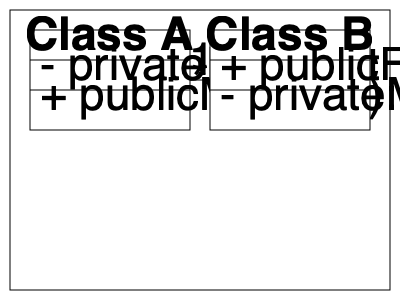Analyze the given UML class diagram and determine the relationship between Class A and Class B. What potential design issues or concerns should be considered when implementing this relationship? To analyze the UML class diagram and determine the relationship between Class A and Class B, let's follow these steps:

1. Identify the classes:
   - We have two classes: Class A and Class B

2. Examine the relationship between the classes:
   - There is a line connecting Class A and Class B
   - The line has a "1" on Class A's side and a "*" on Class B's side

3. Interpret the relationship:
   - This indicates a one-to-many association between Class A and Class B
   - One instance of Class A is associated with multiple instances of Class B

4. Analyze the class structures:
   - Class A has a private field and a public method
   - Class B has a public field and a private method

5. Consider potential design issues and concerns:
   a. Encapsulation: 
      - Class B has a public field, which may violate encapsulation principles
   b. Dependency:
      - Class A might have too much control over multiple instances of Class B
   c. Coupling:
      - The one-to-many relationship could lead to tight coupling between the classes
   d. Scalability:
      - As the number of Class B instances grows, it might impact performance
   e. Maintenance:
      - Changes in either class could affect the other, potentially making maintenance difficult
   f. Thread safety:
      - If multiple threads access the relationship, synchronization might be necessary

6. Potential improvements:
   - Consider using interfaces to reduce coupling
   - Implement proper encapsulation for Class B's public field
   - Use design patterns like Observer or Mediator to manage the relationship more effectively
   - Implement lazy loading or pagination if dealing with large collections of Class B instances

When implementing this relationship, careful consideration should be given to these issues to ensure a robust and maintainable design.
Answer: One-to-many association with potential issues in encapsulation, coupling, and scalability. 